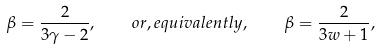<formula> <loc_0><loc_0><loc_500><loc_500>\beta = \frac { 2 } { 3 \gamma - 2 } , \quad o r , e q u i v a l e n t l y , \quad \beta = \frac { 2 } { 3 w + 1 } ,</formula> 